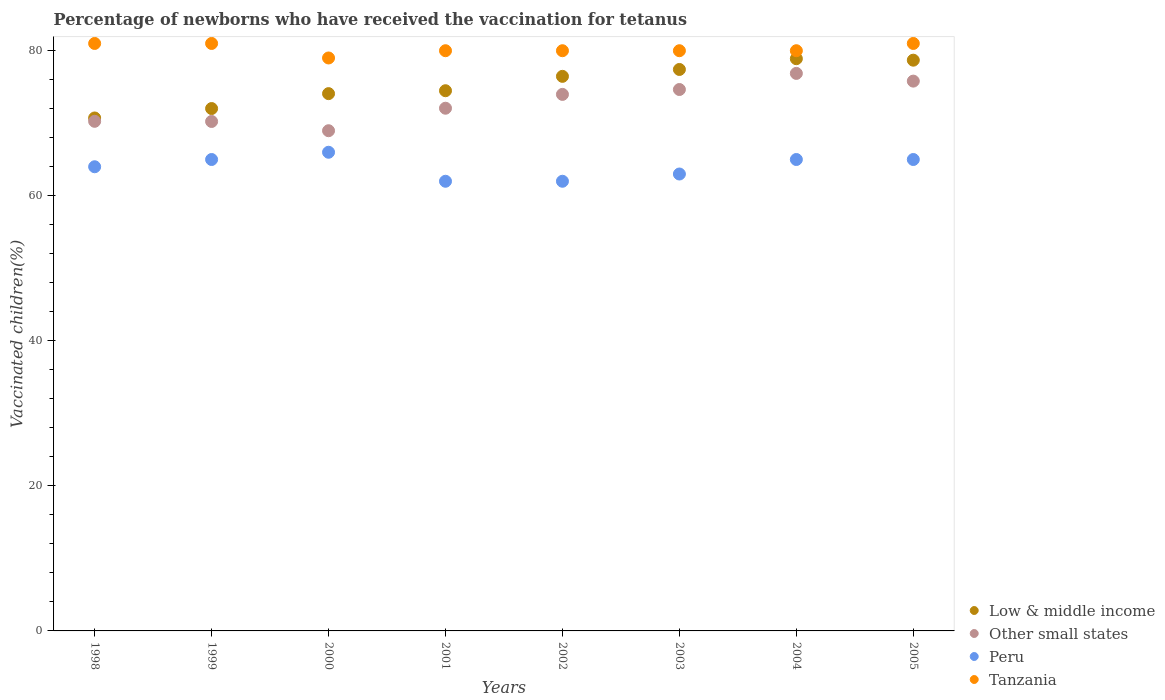How many different coloured dotlines are there?
Offer a terse response. 4. Is the number of dotlines equal to the number of legend labels?
Provide a succinct answer. Yes. What is the percentage of vaccinated children in Tanzania in 2004?
Provide a succinct answer. 80. Across all years, what is the maximum percentage of vaccinated children in Tanzania?
Your answer should be compact. 81. Across all years, what is the minimum percentage of vaccinated children in Tanzania?
Provide a succinct answer. 79. In which year was the percentage of vaccinated children in Tanzania maximum?
Offer a terse response. 1998. What is the total percentage of vaccinated children in Low & middle income in the graph?
Your answer should be very brief. 602.8. What is the difference between the percentage of vaccinated children in Tanzania in 1998 and that in 2004?
Provide a short and direct response. 1. What is the average percentage of vaccinated children in Peru per year?
Keep it short and to the point. 64. In the year 2002, what is the difference between the percentage of vaccinated children in Low & middle income and percentage of vaccinated children in Peru?
Ensure brevity in your answer.  14.47. What is the ratio of the percentage of vaccinated children in Other small states in 2001 to that in 2003?
Your answer should be compact. 0.97. What is the difference between the highest and the second highest percentage of vaccinated children in Tanzania?
Your answer should be compact. 0. What is the difference between the highest and the lowest percentage of vaccinated children in Other small states?
Provide a short and direct response. 7.9. In how many years, is the percentage of vaccinated children in Peru greater than the average percentage of vaccinated children in Peru taken over all years?
Offer a very short reply. 4. Is the sum of the percentage of vaccinated children in Other small states in 1999 and 2003 greater than the maximum percentage of vaccinated children in Tanzania across all years?
Your answer should be very brief. Yes. Is it the case that in every year, the sum of the percentage of vaccinated children in Peru and percentage of vaccinated children in Other small states  is greater than the sum of percentage of vaccinated children in Tanzania and percentage of vaccinated children in Low & middle income?
Make the answer very short. Yes. Is it the case that in every year, the sum of the percentage of vaccinated children in Other small states and percentage of vaccinated children in Tanzania  is greater than the percentage of vaccinated children in Low & middle income?
Keep it short and to the point. Yes. How many dotlines are there?
Keep it short and to the point. 4. How many years are there in the graph?
Your answer should be compact. 8. What is the difference between two consecutive major ticks on the Y-axis?
Your answer should be very brief. 20. Are the values on the major ticks of Y-axis written in scientific E-notation?
Offer a very short reply. No. Does the graph contain any zero values?
Ensure brevity in your answer.  No. Does the graph contain grids?
Provide a short and direct response. No. What is the title of the graph?
Keep it short and to the point. Percentage of newborns who have received the vaccination for tetanus. Does "Gambia, The" appear as one of the legend labels in the graph?
Your answer should be very brief. No. What is the label or title of the Y-axis?
Your answer should be compact. Vaccinated children(%). What is the Vaccinated children(%) in Low & middle income in 1998?
Provide a succinct answer. 70.73. What is the Vaccinated children(%) in Other small states in 1998?
Offer a very short reply. 70.27. What is the Vaccinated children(%) in Low & middle income in 1999?
Offer a terse response. 72.03. What is the Vaccinated children(%) of Other small states in 1999?
Your response must be concise. 70.24. What is the Vaccinated children(%) of Tanzania in 1999?
Provide a short and direct response. 81. What is the Vaccinated children(%) of Low & middle income in 2000?
Your answer should be very brief. 74.08. What is the Vaccinated children(%) in Other small states in 2000?
Your answer should be very brief. 68.97. What is the Vaccinated children(%) in Tanzania in 2000?
Your response must be concise. 79. What is the Vaccinated children(%) of Low & middle income in 2001?
Ensure brevity in your answer.  74.48. What is the Vaccinated children(%) in Other small states in 2001?
Offer a terse response. 72.07. What is the Vaccinated children(%) of Tanzania in 2001?
Ensure brevity in your answer.  80. What is the Vaccinated children(%) in Low & middle income in 2002?
Ensure brevity in your answer.  76.47. What is the Vaccinated children(%) of Other small states in 2002?
Make the answer very short. 73.98. What is the Vaccinated children(%) in Tanzania in 2002?
Your answer should be very brief. 80. What is the Vaccinated children(%) of Low & middle income in 2003?
Your answer should be compact. 77.41. What is the Vaccinated children(%) in Other small states in 2003?
Keep it short and to the point. 74.65. What is the Vaccinated children(%) of Tanzania in 2003?
Provide a short and direct response. 80. What is the Vaccinated children(%) in Low & middle income in 2004?
Offer a terse response. 78.9. What is the Vaccinated children(%) in Other small states in 2004?
Offer a terse response. 76.87. What is the Vaccinated children(%) of Tanzania in 2004?
Provide a succinct answer. 80. What is the Vaccinated children(%) of Low & middle income in 2005?
Make the answer very short. 78.7. What is the Vaccinated children(%) of Other small states in 2005?
Your answer should be compact. 75.81. What is the Vaccinated children(%) in Peru in 2005?
Keep it short and to the point. 65. Across all years, what is the maximum Vaccinated children(%) of Low & middle income?
Ensure brevity in your answer.  78.9. Across all years, what is the maximum Vaccinated children(%) in Other small states?
Keep it short and to the point. 76.87. Across all years, what is the maximum Vaccinated children(%) of Tanzania?
Your response must be concise. 81. Across all years, what is the minimum Vaccinated children(%) in Low & middle income?
Keep it short and to the point. 70.73. Across all years, what is the minimum Vaccinated children(%) in Other small states?
Keep it short and to the point. 68.97. Across all years, what is the minimum Vaccinated children(%) of Tanzania?
Your response must be concise. 79. What is the total Vaccinated children(%) in Low & middle income in the graph?
Provide a succinct answer. 602.8. What is the total Vaccinated children(%) of Other small states in the graph?
Offer a very short reply. 582.86. What is the total Vaccinated children(%) of Peru in the graph?
Keep it short and to the point. 512. What is the total Vaccinated children(%) of Tanzania in the graph?
Make the answer very short. 642. What is the difference between the Vaccinated children(%) in Low & middle income in 1998 and that in 1999?
Offer a terse response. -1.3. What is the difference between the Vaccinated children(%) in Other small states in 1998 and that in 1999?
Provide a short and direct response. 0.02. What is the difference between the Vaccinated children(%) in Tanzania in 1998 and that in 1999?
Offer a very short reply. 0. What is the difference between the Vaccinated children(%) in Low & middle income in 1998 and that in 2000?
Offer a very short reply. -3.36. What is the difference between the Vaccinated children(%) of Other small states in 1998 and that in 2000?
Offer a terse response. 1.3. What is the difference between the Vaccinated children(%) of Low & middle income in 1998 and that in 2001?
Make the answer very short. -3.76. What is the difference between the Vaccinated children(%) of Other small states in 1998 and that in 2001?
Your answer should be very brief. -1.81. What is the difference between the Vaccinated children(%) in Peru in 1998 and that in 2001?
Keep it short and to the point. 2. What is the difference between the Vaccinated children(%) of Tanzania in 1998 and that in 2001?
Your answer should be compact. 1. What is the difference between the Vaccinated children(%) of Low & middle income in 1998 and that in 2002?
Make the answer very short. -5.74. What is the difference between the Vaccinated children(%) of Other small states in 1998 and that in 2002?
Provide a succinct answer. -3.71. What is the difference between the Vaccinated children(%) of Tanzania in 1998 and that in 2002?
Provide a short and direct response. 1. What is the difference between the Vaccinated children(%) in Low & middle income in 1998 and that in 2003?
Keep it short and to the point. -6.69. What is the difference between the Vaccinated children(%) of Other small states in 1998 and that in 2003?
Offer a terse response. -4.38. What is the difference between the Vaccinated children(%) in Low & middle income in 1998 and that in 2004?
Provide a succinct answer. -8.17. What is the difference between the Vaccinated children(%) of Other small states in 1998 and that in 2004?
Provide a succinct answer. -6.61. What is the difference between the Vaccinated children(%) of Peru in 1998 and that in 2004?
Offer a terse response. -1. What is the difference between the Vaccinated children(%) of Low & middle income in 1998 and that in 2005?
Ensure brevity in your answer.  -7.97. What is the difference between the Vaccinated children(%) in Other small states in 1998 and that in 2005?
Provide a short and direct response. -5.54. What is the difference between the Vaccinated children(%) in Peru in 1998 and that in 2005?
Keep it short and to the point. -1. What is the difference between the Vaccinated children(%) in Tanzania in 1998 and that in 2005?
Make the answer very short. 0. What is the difference between the Vaccinated children(%) of Low & middle income in 1999 and that in 2000?
Your response must be concise. -2.06. What is the difference between the Vaccinated children(%) in Other small states in 1999 and that in 2000?
Make the answer very short. 1.27. What is the difference between the Vaccinated children(%) of Tanzania in 1999 and that in 2000?
Your response must be concise. 2. What is the difference between the Vaccinated children(%) in Low & middle income in 1999 and that in 2001?
Offer a very short reply. -2.46. What is the difference between the Vaccinated children(%) in Other small states in 1999 and that in 2001?
Keep it short and to the point. -1.83. What is the difference between the Vaccinated children(%) in Peru in 1999 and that in 2001?
Offer a terse response. 3. What is the difference between the Vaccinated children(%) of Tanzania in 1999 and that in 2001?
Your answer should be very brief. 1. What is the difference between the Vaccinated children(%) of Low & middle income in 1999 and that in 2002?
Make the answer very short. -4.44. What is the difference between the Vaccinated children(%) of Other small states in 1999 and that in 2002?
Your answer should be compact. -3.73. What is the difference between the Vaccinated children(%) of Peru in 1999 and that in 2002?
Ensure brevity in your answer.  3. What is the difference between the Vaccinated children(%) in Tanzania in 1999 and that in 2002?
Offer a very short reply. 1. What is the difference between the Vaccinated children(%) in Low & middle income in 1999 and that in 2003?
Your answer should be very brief. -5.39. What is the difference between the Vaccinated children(%) of Other small states in 1999 and that in 2003?
Keep it short and to the point. -4.41. What is the difference between the Vaccinated children(%) of Tanzania in 1999 and that in 2003?
Ensure brevity in your answer.  1. What is the difference between the Vaccinated children(%) of Low & middle income in 1999 and that in 2004?
Your response must be concise. -6.87. What is the difference between the Vaccinated children(%) in Other small states in 1999 and that in 2004?
Your answer should be compact. -6.63. What is the difference between the Vaccinated children(%) of Tanzania in 1999 and that in 2004?
Your answer should be very brief. 1. What is the difference between the Vaccinated children(%) in Low & middle income in 1999 and that in 2005?
Give a very brief answer. -6.67. What is the difference between the Vaccinated children(%) of Other small states in 1999 and that in 2005?
Give a very brief answer. -5.56. What is the difference between the Vaccinated children(%) of Peru in 1999 and that in 2005?
Offer a terse response. 0. What is the difference between the Vaccinated children(%) of Tanzania in 1999 and that in 2005?
Keep it short and to the point. 0. What is the difference between the Vaccinated children(%) of Low & middle income in 2000 and that in 2001?
Your answer should be very brief. -0.4. What is the difference between the Vaccinated children(%) of Other small states in 2000 and that in 2001?
Your response must be concise. -3.1. What is the difference between the Vaccinated children(%) of Peru in 2000 and that in 2001?
Your answer should be compact. 4. What is the difference between the Vaccinated children(%) in Tanzania in 2000 and that in 2001?
Give a very brief answer. -1. What is the difference between the Vaccinated children(%) of Low & middle income in 2000 and that in 2002?
Keep it short and to the point. -2.38. What is the difference between the Vaccinated children(%) in Other small states in 2000 and that in 2002?
Keep it short and to the point. -5.01. What is the difference between the Vaccinated children(%) of Tanzania in 2000 and that in 2002?
Offer a terse response. -1. What is the difference between the Vaccinated children(%) of Low & middle income in 2000 and that in 2003?
Your answer should be compact. -3.33. What is the difference between the Vaccinated children(%) in Other small states in 2000 and that in 2003?
Make the answer very short. -5.68. What is the difference between the Vaccinated children(%) in Tanzania in 2000 and that in 2003?
Your response must be concise. -1. What is the difference between the Vaccinated children(%) of Low & middle income in 2000 and that in 2004?
Give a very brief answer. -4.82. What is the difference between the Vaccinated children(%) in Other small states in 2000 and that in 2004?
Keep it short and to the point. -7.9. What is the difference between the Vaccinated children(%) in Peru in 2000 and that in 2004?
Your response must be concise. 1. What is the difference between the Vaccinated children(%) in Low & middle income in 2000 and that in 2005?
Provide a short and direct response. -4.61. What is the difference between the Vaccinated children(%) of Other small states in 2000 and that in 2005?
Your answer should be very brief. -6.84. What is the difference between the Vaccinated children(%) of Low & middle income in 2001 and that in 2002?
Your answer should be very brief. -1.98. What is the difference between the Vaccinated children(%) in Other small states in 2001 and that in 2002?
Offer a terse response. -1.91. What is the difference between the Vaccinated children(%) of Tanzania in 2001 and that in 2002?
Provide a short and direct response. 0. What is the difference between the Vaccinated children(%) of Low & middle income in 2001 and that in 2003?
Provide a succinct answer. -2.93. What is the difference between the Vaccinated children(%) of Other small states in 2001 and that in 2003?
Provide a short and direct response. -2.58. What is the difference between the Vaccinated children(%) of Low & middle income in 2001 and that in 2004?
Your answer should be very brief. -4.42. What is the difference between the Vaccinated children(%) in Other small states in 2001 and that in 2004?
Your answer should be compact. -4.8. What is the difference between the Vaccinated children(%) in Peru in 2001 and that in 2004?
Provide a succinct answer. -3. What is the difference between the Vaccinated children(%) in Low & middle income in 2001 and that in 2005?
Offer a terse response. -4.21. What is the difference between the Vaccinated children(%) in Other small states in 2001 and that in 2005?
Ensure brevity in your answer.  -3.74. What is the difference between the Vaccinated children(%) in Peru in 2001 and that in 2005?
Provide a short and direct response. -3. What is the difference between the Vaccinated children(%) in Tanzania in 2001 and that in 2005?
Provide a short and direct response. -1. What is the difference between the Vaccinated children(%) of Low & middle income in 2002 and that in 2003?
Provide a succinct answer. -0.95. What is the difference between the Vaccinated children(%) in Other small states in 2002 and that in 2003?
Your answer should be very brief. -0.67. What is the difference between the Vaccinated children(%) of Low & middle income in 2002 and that in 2004?
Make the answer very short. -2.43. What is the difference between the Vaccinated children(%) of Other small states in 2002 and that in 2004?
Your answer should be compact. -2.9. What is the difference between the Vaccinated children(%) of Low & middle income in 2002 and that in 2005?
Offer a very short reply. -2.23. What is the difference between the Vaccinated children(%) in Other small states in 2002 and that in 2005?
Your answer should be very brief. -1.83. What is the difference between the Vaccinated children(%) of Low & middle income in 2003 and that in 2004?
Offer a terse response. -1.48. What is the difference between the Vaccinated children(%) in Other small states in 2003 and that in 2004?
Make the answer very short. -2.22. What is the difference between the Vaccinated children(%) of Tanzania in 2003 and that in 2004?
Make the answer very short. 0. What is the difference between the Vaccinated children(%) in Low & middle income in 2003 and that in 2005?
Provide a succinct answer. -1.28. What is the difference between the Vaccinated children(%) of Other small states in 2003 and that in 2005?
Give a very brief answer. -1.16. What is the difference between the Vaccinated children(%) of Peru in 2003 and that in 2005?
Offer a very short reply. -2. What is the difference between the Vaccinated children(%) in Low & middle income in 2004 and that in 2005?
Your answer should be very brief. 0.2. What is the difference between the Vaccinated children(%) of Other small states in 2004 and that in 2005?
Your answer should be very brief. 1.06. What is the difference between the Vaccinated children(%) of Peru in 2004 and that in 2005?
Provide a succinct answer. 0. What is the difference between the Vaccinated children(%) in Low & middle income in 1998 and the Vaccinated children(%) in Other small states in 1999?
Your answer should be very brief. 0.48. What is the difference between the Vaccinated children(%) of Low & middle income in 1998 and the Vaccinated children(%) of Peru in 1999?
Your answer should be compact. 5.73. What is the difference between the Vaccinated children(%) in Low & middle income in 1998 and the Vaccinated children(%) in Tanzania in 1999?
Give a very brief answer. -10.27. What is the difference between the Vaccinated children(%) of Other small states in 1998 and the Vaccinated children(%) of Peru in 1999?
Your answer should be very brief. 5.27. What is the difference between the Vaccinated children(%) in Other small states in 1998 and the Vaccinated children(%) in Tanzania in 1999?
Your answer should be very brief. -10.73. What is the difference between the Vaccinated children(%) of Peru in 1998 and the Vaccinated children(%) of Tanzania in 1999?
Make the answer very short. -17. What is the difference between the Vaccinated children(%) in Low & middle income in 1998 and the Vaccinated children(%) in Other small states in 2000?
Ensure brevity in your answer.  1.76. What is the difference between the Vaccinated children(%) in Low & middle income in 1998 and the Vaccinated children(%) in Peru in 2000?
Provide a short and direct response. 4.73. What is the difference between the Vaccinated children(%) in Low & middle income in 1998 and the Vaccinated children(%) in Tanzania in 2000?
Offer a terse response. -8.27. What is the difference between the Vaccinated children(%) in Other small states in 1998 and the Vaccinated children(%) in Peru in 2000?
Provide a succinct answer. 4.27. What is the difference between the Vaccinated children(%) of Other small states in 1998 and the Vaccinated children(%) of Tanzania in 2000?
Your response must be concise. -8.73. What is the difference between the Vaccinated children(%) of Peru in 1998 and the Vaccinated children(%) of Tanzania in 2000?
Your response must be concise. -15. What is the difference between the Vaccinated children(%) in Low & middle income in 1998 and the Vaccinated children(%) in Other small states in 2001?
Make the answer very short. -1.34. What is the difference between the Vaccinated children(%) in Low & middle income in 1998 and the Vaccinated children(%) in Peru in 2001?
Your answer should be very brief. 8.73. What is the difference between the Vaccinated children(%) in Low & middle income in 1998 and the Vaccinated children(%) in Tanzania in 2001?
Give a very brief answer. -9.27. What is the difference between the Vaccinated children(%) in Other small states in 1998 and the Vaccinated children(%) in Peru in 2001?
Give a very brief answer. 8.27. What is the difference between the Vaccinated children(%) of Other small states in 1998 and the Vaccinated children(%) of Tanzania in 2001?
Ensure brevity in your answer.  -9.73. What is the difference between the Vaccinated children(%) in Peru in 1998 and the Vaccinated children(%) in Tanzania in 2001?
Offer a very short reply. -16. What is the difference between the Vaccinated children(%) of Low & middle income in 1998 and the Vaccinated children(%) of Other small states in 2002?
Provide a short and direct response. -3.25. What is the difference between the Vaccinated children(%) in Low & middle income in 1998 and the Vaccinated children(%) in Peru in 2002?
Offer a terse response. 8.73. What is the difference between the Vaccinated children(%) in Low & middle income in 1998 and the Vaccinated children(%) in Tanzania in 2002?
Keep it short and to the point. -9.27. What is the difference between the Vaccinated children(%) of Other small states in 1998 and the Vaccinated children(%) of Peru in 2002?
Offer a very short reply. 8.27. What is the difference between the Vaccinated children(%) of Other small states in 1998 and the Vaccinated children(%) of Tanzania in 2002?
Provide a short and direct response. -9.73. What is the difference between the Vaccinated children(%) of Peru in 1998 and the Vaccinated children(%) of Tanzania in 2002?
Provide a succinct answer. -16. What is the difference between the Vaccinated children(%) of Low & middle income in 1998 and the Vaccinated children(%) of Other small states in 2003?
Your response must be concise. -3.92. What is the difference between the Vaccinated children(%) in Low & middle income in 1998 and the Vaccinated children(%) in Peru in 2003?
Offer a terse response. 7.73. What is the difference between the Vaccinated children(%) of Low & middle income in 1998 and the Vaccinated children(%) of Tanzania in 2003?
Your answer should be compact. -9.27. What is the difference between the Vaccinated children(%) of Other small states in 1998 and the Vaccinated children(%) of Peru in 2003?
Give a very brief answer. 7.27. What is the difference between the Vaccinated children(%) in Other small states in 1998 and the Vaccinated children(%) in Tanzania in 2003?
Give a very brief answer. -9.73. What is the difference between the Vaccinated children(%) in Low & middle income in 1998 and the Vaccinated children(%) in Other small states in 2004?
Keep it short and to the point. -6.15. What is the difference between the Vaccinated children(%) of Low & middle income in 1998 and the Vaccinated children(%) of Peru in 2004?
Make the answer very short. 5.73. What is the difference between the Vaccinated children(%) of Low & middle income in 1998 and the Vaccinated children(%) of Tanzania in 2004?
Offer a very short reply. -9.27. What is the difference between the Vaccinated children(%) of Other small states in 1998 and the Vaccinated children(%) of Peru in 2004?
Offer a terse response. 5.27. What is the difference between the Vaccinated children(%) in Other small states in 1998 and the Vaccinated children(%) in Tanzania in 2004?
Provide a succinct answer. -9.73. What is the difference between the Vaccinated children(%) of Low & middle income in 1998 and the Vaccinated children(%) of Other small states in 2005?
Your answer should be compact. -5.08. What is the difference between the Vaccinated children(%) in Low & middle income in 1998 and the Vaccinated children(%) in Peru in 2005?
Ensure brevity in your answer.  5.73. What is the difference between the Vaccinated children(%) of Low & middle income in 1998 and the Vaccinated children(%) of Tanzania in 2005?
Your answer should be very brief. -10.27. What is the difference between the Vaccinated children(%) in Other small states in 1998 and the Vaccinated children(%) in Peru in 2005?
Ensure brevity in your answer.  5.27. What is the difference between the Vaccinated children(%) in Other small states in 1998 and the Vaccinated children(%) in Tanzania in 2005?
Offer a terse response. -10.73. What is the difference between the Vaccinated children(%) of Low & middle income in 1999 and the Vaccinated children(%) of Other small states in 2000?
Keep it short and to the point. 3.06. What is the difference between the Vaccinated children(%) in Low & middle income in 1999 and the Vaccinated children(%) in Peru in 2000?
Your response must be concise. 6.03. What is the difference between the Vaccinated children(%) in Low & middle income in 1999 and the Vaccinated children(%) in Tanzania in 2000?
Offer a terse response. -6.97. What is the difference between the Vaccinated children(%) in Other small states in 1999 and the Vaccinated children(%) in Peru in 2000?
Provide a short and direct response. 4.24. What is the difference between the Vaccinated children(%) in Other small states in 1999 and the Vaccinated children(%) in Tanzania in 2000?
Make the answer very short. -8.76. What is the difference between the Vaccinated children(%) in Low & middle income in 1999 and the Vaccinated children(%) in Other small states in 2001?
Your response must be concise. -0.04. What is the difference between the Vaccinated children(%) of Low & middle income in 1999 and the Vaccinated children(%) of Peru in 2001?
Your response must be concise. 10.03. What is the difference between the Vaccinated children(%) in Low & middle income in 1999 and the Vaccinated children(%) in Tanzania in 2001?
Make the answer very short. -7.97. What is the difference between the Vaccinated children(%) in Other small states in 1999 and the Vaccinated children(%) in Peru in 2001?
Ensure brevity in your answer.  8.24. What is the difference between the Vaccinated children(%) of Other small states in 1999 and the Vaccinated children(%) of Tanzania in 2001?
Keep it short and to the point. -9.76. What is the difference between the Vaccinated children(%) in Low & middle income in 1999 and the Vaccinated children(%) in Other small states in 2002?
Give a very brief answer. -1.95. What is the difference between the Vaccinated children(%) in Low & middle income in 1999 and the Vaccinated children(%) in Peru in 2002?
Provide a succinct answer. 10.03. What is the difference between the Vaccinated children(%) of Low & middle income in 1999 and the Vaccinated children(%) of Tanzania in 2002?
Provide a short and direct response. -7.97. What is the difference between the Vaccinated children(%) in Other small states in 1999 and the Vaccinated children(%) in Peru in 2002?
Give a very brief answer. 8.24. What is the difference between the Vaccinated children(%) in Other small states in 1999 and the Vaccinated children(%) in Tanzania in 2002?
Provide a succinct answer. -9.76. What is the difference between the Vaccinated children(%) in Low & middle income in 1999 and the Vaccinated children(%) in Other small states in 2003?
Ensure brevity in your answer.  -2.62. What is the difference between the Vaccinated children(%) in Low & middle income in 1999 and the Vaccinated children(%) in Peru in 2003?
Ensure brevity in your answer.  9.03. What is the difference between the Vaccinated children(%) of Low & middle income in 1999 and the Vaccinated children(%) of Tanzania in 2003?
Keep it short and to the point. -7.97. What is the difference between the Vaccinated children(%) of Other small states in 1999 and the Vaccinated children(%) of Peru in 2003?
Provide a succinct answer. 7.24. What is the difference between the Vaccinated children(%) in Other small states in 1999 and the Vaccinated children(%) in Tanzania in 2003?
Your response must be concise. -9.76. What is the difference between the Vaccinated children(%) in Peru in 1999 and the Vaccinated children(%) in Tanzania in 2003?
Ensure brevity in your answer.  -15. What is the difference between the Vaccinated children(%) in Low & middle income in 1999 and the Vaccinated children(%) in Other small states in 2004?
Your answer should be very brief. -4.85. What is the difference between the Vaccinated children(%) in Low & middle income in 1999 and the Vaccinated children(%) in Peru in 2004?
Your answer should be very brief. 7.03. What is the difference between the Vaccinated children(%) of Low & middle income in 1999 and the Vaccinated children(%) of Tanzania in 2004?
Make the answer very short. -7.97. What is the difference between the Vaccinated children(%) in Other small states in 1999 and the Vaccinated children(%) in Peru in 2004?
Make the answer very short. 5.24. What is the difference between the Vaccinated children(%) of Other small states in 1999 and the Vaccinated children(%) of Tanzania in 2004?
Ensure brevity in your answer.  -9.76. What is the difference between the Vaccinated children(%) of Peru in 1999 and the Vaccinated children(%) of Tanzania in 2004?
Offer a very short reply. -15. What is the difference between the Vaccinated children(%) in Low & middle income in 1999 and the Vaccinated children(%) in Other small states in 2005?
Provide a short and direct response. -3.78. What is the difference between the Vaccinated children(%) of Low & middle income in 1999 and the Vaccinated children(%) of Peru in 2005?
Ensure brevity in your answer.  7.03. What is the difference between the Vaccinated children(%) in Low & middle income in 1999 and the Vaccinated children(%) in Tanzania in 2005?
Ensure brevity in your answer.  -8.97. What is the difference between the Vaccinated children(%) in Other small states in 1999 and the Vaccinated children(%) in Peru in 2005?
Your answer should be compact. 5.24. What is the difference between the Vaccinated children(%) in Other small states in 1999 and the Vaccinated children(%) in Tanzania in 2005?
Your answer should be compact. -10.76. What is the difference between the Vaccinated children(%) of Peru in 1999 and the Vaccinated children(%) of Tanzania in 2005?
Offer a terse response. -16. What is the difference between the Vaccinated children(%) of Low & middle income in 2000 and the Vaccinated children(%) of Other small states in 2001?
Make the answer very short. 2.01. What is the difference between the Vaccinated children(%) of Low & middle income in 2000 and the Vaccinated children(%) of Peru in 2001?
Make the answer very short. 12.08. What is the difference between the Vaccinated children(%) in Low & middle income in 2000 and the Vaccinated children(%) in Tanzania in 2001?
Give a very brief answer. -5.92. What is the difference between the Vaccinated children(%) of Other small states in 2000 and the Vaccinated children(%) of Peru in 2001?
Make the answer very short. 6.97. What is the difference between the Vaccinated children(%) in Other small states in 2000 and the Vaccinated children(%) in Tanzania in 2001?
Make the answer very short. -11.03. What is the difference between the Vaccinated children(%) in Low & middle income in 2000 and the Vaccinated children(%) in Other small states in 2002?
Make the answer very short. 0.11. What is the difference between the Vaccinated children(%) in Low & middle income in 2000 and the Vaccinated children(%) in Peru in 2002?
Keep it short and to the point. 12.08. What is the difference between the Vaccinated children(%) of Low & middle income in 2000 and the Vaccinated children(%) of Tanzania in 2002?
Your answer should be compact. -5.92. What is the difference between the Vaccinated children(%) in Other small states in 2000 and the Vaccinated children(%) in Peru in 2002?
Make the answer very short. 6.97. What is the difference between the Vaccinated children(%) in Other small states in 2000 and the Vaccinated children(%) in Tanzania in 2002?
Give a very brief answer. -11.03. What is the difference between the Vaccinated children(%) of Peru in 2000 and the Vaccinated children(%) of Tanzania in 2002?
Provide a succinct answer. -14. What is the difference between the Vaccinated children(%) in Low & middle income in 2000 and the Vaccinated children(%) in Other small states in 2003?
Offer a terse response. -0.57. What is the difference between the Vaccinated children(%) of Low & middle income in 2000 and the Vaccinated children(%) of Peru in 2003?
Keep it short and to the point. 11.08. What is the difference between the Vaccinated children(%) of Low & middle income in 2000 and the Vaccinated children(%) of Tanzania in 2003?
Your answer should be compact. -5.92. What is the difference between the Vaccinated children(%) of Other small states in 2000 and the Vaccinated children(%) of Peru in 2003?
Make the answer very short. 5.97. What is the difference between the Vaccinated children(%) in Other small states in 2000 and the Vaccinated children(%) in Tanzania in 2003?
Offer a very short reply. -11.03. What is the difference between the Vaccinated children(%) in Peru in 2000 and the Vaccinated children(%) in Tanzania in 2003?
Give a very brief answer. -14. What is the difference between the Vaccinated children(%) of Low & middle income in 2000 and the Vaccinated children(%) of Other small states in 2004?
Provide a succinct answer. -2.79. What is the difference between the Vaccinated children(%) in Low & middle income in 2000 and the Vaccinated children(%) in Peru in 2004?
Offer a terse response. 9.08. What is the difference between the Vaccinated children(%) of Low & middle income in 2000 and the Vaccinated children(%) of Tanzania in 2004?
Offer a terse response. -5.92. What is the difference between the Vaccinated children(%) of Other small states in 2000 and the Vaccinated children(%) of Peru in 2004?
Make the answer very short. 3.97. What is the difference between the Vaccinated children(%) in Other small states in 2000 and the Vaccinated children(%) in Tanzania in 2004?
Your answer should be compact. -11.03. What is the difference between the Vaccinated children(%) of Peru in 2000 and the Vaccinated children(%) of Tanzania in 2004?
Give a very brief answer. -14. What is the difference between the Vaccinated children(%) of Low & middle income in 2000 and the Vaccinated children(%) of Other small states in 2005?
Make the answer very short. -1.73. What is the difference between the Vaccinated children(%) in Low & middle income in 2000 and the Vaccinated children(%) in Peru in 2005?
Offer a terse response. 9.08. What is the difference between the Vaccinated children(%) of Low & middle income in 2000 and the Vaccinated children(%) of Tanzania in 2005?
Offer a terse response. -6.92. What is the difference between the Vaccinated children(%) in Other small states in 2000 and the Vaccinated children(%) in Peru in 2005?
Offer a terse response. 3.97. What is the difference between the Vaccinated children(%) of Other small states in 2000 and the Vaccinated children(%) of Tanzania in 2005?
Ensure brevity in your answer.  -12.03. What is the difference between the Vaccinated children(%) in Peru in 2000 and the Vaccinated children(%) in Tanzania in 2005?
Make the answer very short. -15. What is the difference between the Vaccinated children(%) in Low & middle income in 2001 and the Vaccinated children(%) in Other small states in 2002?
Offer a very short reply. 0.51. What is the difference between the Vaccinated children(%) of Low & middle income in 2001 and the Vaccinated children(%) of Peru in 2002?
Provide a succinct answer. 12.48. What is the difference between the Vaccinated children(%) of Low & middle income in 2001 and the Vaccinated children(%) of Tanzania in 2002?
Give a very brief answer. -5.52. What is the difference between the Vaccinated children(%) in Other small states in 2001 and the Vaccinated children(%) in Peru in 2002?
Provide a short and direct response. 10.07. What is the difference between the Vaccinated children(%) of Other small states in 2001 and the Vaccinated children(%) of Tanzania in 2002?
Give a very brief answer. -7.93. What is the difference between the Vaccinated children(%) of Peru in 2001 and the Vaccinated children(%) of Tanzania in 2002?
Offer a very short reply. -18. What is the difference between the Vaccinated children(%) in Low & middle income in 2001 and the Vaccinated children(%) in Other small states in 2003?
Keep it short and to the point. -0.17. What is the difference between the Vaccinated children(%) in Low & middle income in 2001 and the Vaccinated children(%) in Peru in 2003?
Your answer should be compact. 11.48. What is the difference between the Vaccinated children(%) in Low & middle income in 2001 and the Vaccinated children(%) in Tanzania in 2003?
Your response must be concise. -5.52. What is the difference between the Vaccinated children(%) of Other small states in 2001 and the Vaccinated children(%) of Peru in 2003?
Provide a succinct answer. 9.07. What is the difference between the Vaccinated children(%) in Other small states in 2001 and the Vaccinated children(%) in Tanzania in 2003?
Offer a terse response. -7.93. What is the difference between the Vaccinated children(%) of Peru in 2001 and the Vaccinated children(%) of Tanzania in 2003?
Keep it short and to the point. -18. What is the difference between the Vaccinated children(%) in Low & middle income in 2001 and the Vaccinated children(%) in Other small states in 2004?
Make the answer very short. -2.39. What is the difference between the Vaccinated children(%) in Low & middle income in 2001 and the Vaccinated children(%) in Peru in 2004?
Offer a terse response. 9.48. What is the difference between the Vaccinated children(%) of Low & middle income in 2001 and the Vaccinated children(%) of Tanzania in 2004?
Make the answer very short. -5.52. What is the difference between the Vaccinated children(%) of Other small states in 2001 and the Vaccinated children(%) of Peru in 2004?
Your answer should be very brief. 7.07. What is the difference between the Vaccinated children(%) in Other small states in 2001 and the Vaccinated children(%) in Tanzania in 2004?
Your answer should be compact. -7.93. What is the difference between the Vaccinated children(%) of Low & middle income in 2001 and the Vaccinated children(%) of Other small states in 2005?
Your answer should be very brief. -1.32. What is the difference between the Vaccinated children(%) of Low & middle income in 2001 and the Vaccinated children(%) of Peru in 2005?
Offer a very short reply. 9.48. What is the difference between the Vaccinated children(%) in Low & middle income in 2001 and the Vaccinated children(%) in Tanzania in 2005?
Give a very brief answer. -6.52. What is the difference between the Vaccinated children(%) in Other small states in 2001 and the Vaccinated children(%) in Peru in 2005?
Keep it short and to the point. 7.07. What is the difference between the Vaccinated children(%) in Other small states in 2001 and the Vaccinated children(%) in Tanzania in 2005?
Give a very brief answer. -8.93. What is the difference between the Vaccinated children(%) of Low & middle income in 2002 and the Vaccinated children(%) of Other small states in 2003?
Your answer should be compact. 1.81. What is the difference between the Vaccinated children(%) of Low & middle income in 2002 and the Vaccinated children(%) of Peru in 2003?
Provide a succinct answer. 13.47. What is the difference between the Vaccinated children(%) of Low & middle income in 2002 and the Vaccinated children(%) of Tanzania in 2003?
Offer a very short reply. -3.53. What is the difference between the Vaccinated children(%) in Other small states in 2002 and the Vaccinated children(%) in Peru in 2003?
Make the answer very short. 10.98. What is the difference between the Vaccinated children(%) in Other small states in 2002 and the Vaccinated children(%) in Tanzania in 2003?
Provide a succinct answer. -6.02. What is the difference between the Vaccinated children(%) of Low & middle income in 2002 and the Vaccinated children(%) of Other small states in 2004?
Your response must be concise. -0.41. What is the difference between the Vaccinated children(%) of Low & middle income in 2002 and the Vaccinated children(%) of Peru in 2004?
Offer a very short reply. 11.47. What is the difference between the Vaccinated children(%) in Low & middle income in 2002 and the Vaccinated children(%) in Tanzania in 2004?
Your response must be concise. -3.53. What is the difference between the Vaccinated children(%) of Other small states in 2002 and the Vaccinated children(%) of Peru in 2004?
Provide a short and direct response. 8.98. What is the difference between the Vaccinated children(%) of Other small states in 2002 and the Vaccinated children(%) of Tanzania in 2004?
Provide a short and direct response. -6.02. What is the difference between the Vaccinated children(%) of Low & middle income in 2002 and the Vaccinated children(%) of Other small states in 2005?
Give a very brief answer. 0.66. What is the difference between the Vaccinated children(%) in Low & middle income in 2002 and the Vaccinated children(%) in Peru in 2005?
Your response must be concise. 11.47. What is the difference between the Vaccinated children(%) in Low & middle income in 2002 and the Vaccinated children(%) in Tanzania in 2005?
Offer a terse response. -4.53. What is the difference between the Vaccinated children(%) in Other small states in 2002 and the Vaccinated children(%) in Peru in 2005?
Offer a terse response. 8.98. What is the difference between the Vaccinated children(%) in Other small states in 2002 and the Vaccinated children(%) in Tanzania in 2005?
Offer a very short reply. -7.02. What is the difference between the Vaccinated children(%) of Low & middle income in 2003 and the Vaccinated children(%) of Other small states in 2004?
Offer a terse response. 0.54. What is the difference between the Vaccinated children(%) in Low & middle income in 2003 and the Vaccinated children(%) in Peru in 2004?
Ensure brevity in your answer.  12.41. What is the difference between the Vaccinated children(%) in Low & middle income in 2003 and the Vaccinated children(%) in Tanzania in 2004?
Ensure brevity in your answer.  -2.59. What is the difference between the Vaccinated children(%) in Other small states in 2003 and the Vaccinated children(%) in Peru in 2004?
Provide a succinct answer. 9.65. What is the difference between the Vaccinated children(%) in Other small states in 2003 and the Vaccinated children(%) in Tanzania in 2004?
Keep it short and to the point. -5.35. What is the difference between the Vaccinated children(%) in Peru in 2003 and the Vaccinated children(%) in Tanzania in 2004?
Make the answer very short. -17. What is the difference between the Vaccinated children(%) of Low & middle income in 2003 and the Vaccinated children(%) of Other small states in 2005?
Your response must be concise. 1.61. What is the difference between the Vaccinated children(%) in Low & middle income in 2003 and the Vaccinated children(%) in Peru in 2005?
Your response must be concise. 12.41. What is the difference between the Vaccinated children(%) in Low & middle income in 2003 and the Vaccinated children(%) in Tanzania in 2005?
Your answer should be compact. -3.59. What is the difference between the Vaccinated children(%) in Other small states in 2003 and the Vaccinated children(%) in Peru in 2005?
Your response must be concise. 9.65. What is the difference between the Vaccinated children(%) of Other small states in 2003 and the Vaccinated children(%) of Tanzania in 2005?
Provide a succinct answer. -6.35. What is the difference between the Vaccinated children(%) of Low & middle income in 2004 and the Vaccinated children(%) of Other small states in 2005?
Make the answer very short. 3.09. What is the difference between the Vaccinated children(%) of Low & middle income in 2004 and the Vaccinated children(%) of Peru in 2005?
Your response must be concise. 13.9. What is the difference between the Vaccinated children(%) of Low & middle income in 2004 and the Vaccinated children(%) of Tanzania in 2005?
Your answer should be compact. -2.1. What is the difference between the Vaccinated children(%) of Other small states in 2004 and the Vaccinated children(%) of Peru in 2005?
Keep it short and to the point. 11.87. What is the difference between the Vaccinated children(%) of Other small states in 2004 and the Vaccinated children(%) of Tanzania in 2005?
Your response must be concise. -4.13. What is the difference between the Vaccinated children(%) in Peru in 2004 and the Vaccinated children(%) in Tanzania in 2005?
Provide a short and direct response. -16. What is the average Vaccinated children(%) of Low & middle income per year?
Your response must be concise. 75.35. What is the average Vaccinated children(%) in Other small states per year?
Offer a very short reply. 72.86. What is the average Vaccinated children(%) in Tanzania per year?
Your response must be concise. 80.25. In the year 1998, what is the difference between the Vaccinated children(%) of Low & middle income and Vaccinated children(%) of Other small states?
Make the answer very short. 0.46. In the year 1998, what is the difference between the Vaccinated children(%) of Low & middle income and Vaccinated children(%) of Peru?
Your response must be concise. 6.73. In the year 1998, what is the difference between the Vaccinated children(%) of Low & middle income and Vaccinated children(%) of Tanzania?
Your answer should be very brief. -10.27. In the year 1998, what is the difference between the Vaccinated children(%) in Other small states and Vaccinated children(%) in Peru?
Offer a very short reply. 6.27. In the year 1998, what is the difference between the Vaccinated children(%) of Other small states and Vaccinated children(%) of Tanzania?
Your answer should be very brief. -10.73. In the year 1998, what is the difference between the Vaccinated children(%) in Peru and Vaccinated children(%) in Tanzania?
Provide a succinct answer. -17. In the year 1999, what is the difference between the Vaccinated children(%) in Low & middle income and Vaccinated children(%) in Other small states?
Your answer should be compact. 1.78. In the year 1999, what is the difference between the Vaccinated children(%) of Low & middle income and Vaccinated children(%) of Peru?
Offer a terse response. 7.03. In the year 1999, what is the difference between the Vaccinated children(%) of Low & middle income and Vaccinated children(%) of Tanzania?
Give a very brief answer. -8.97. In the year 1999, what is the difference between the Vaccinated children(%) of Other small states and Vaccinated children(%) of Peru?
Offer a terse response. 5.24. In the year 1999, what is the difference between the Vaccinated children(%) in Other small states and Vaccinated children(%) in Tanzania?
Provide a succinct answer. -10.76. In the year 2000, what is the difference between the Vaccinated children(%) of Low & middle income and Vaccinated children(%) of Other small states?
Your answer should be very brief. 5.11. In the year 2000, what is the difference between the Vaccinated children(%) in Low & middle income and Vaccinated children(%) in Peru?
Provide a short and direct response. 8.08. In the year 2000, what is the difference between the Vaccinated children(%) in Low & middle income and Vaccinated children(%) in Tanzania?
Your answer should be very brief. -4.92. In the year 2000, what is the difference between the Vaccinated children(%) of Other small states and Vaccinated children(%) of Peru?
Your answer should be compact. 2.97. In the year 2000, what is the difference between the Vaccinated children(%) of Other small states and Vaccinated children(%) of Tanzania?
Provide a short and direct response. -10.03. In the year 2001, what is the difference between the Vaccinated children(%) of Low & middle income and Vaccinated children(%) of Other small states?
Make the answer very short. 2.41. In the year 2001, what is the difference between the Vaccinated children(%) of Low & middle income and Vaccinated children(%) of Peru?
Keep it short and to the point. 12.48. In the year 2001, what is the difference between the Vaccinated children(%) in Low & middle income and Vaccinated children(%) in Tanzania?
Ensure brevity in your answer.  -5.52. In the year 2001, what is the difference between the Vaccinated children(%) of Other small states and Vaccinated children(%) of Peru?
Offer a terse response. 10.07. In the year 2001, what is the difference between the Vaccinated children(%) in Other small states and Vaccinated children(%) in Tanzania?
Provide a succinct answer. -7.93. In the year 2002, what is the difference between the Vaccinated children(%) of Low & middle income and Vaccinated children(%) of Other small states?
Provide a short and direct response. 2.49. In the year 2002, what is the difference between the Vaccinated children(%) in Low & middle income and Vaccinated children(%) in Peru?
Give a very brief answer. 14.47. In the year 2002, what is the difference between the Vaccinated children(%) in Low & middle income and Vaccinated children(%) in Tanzania?
Offer a very short reply. -3.53. In the year 2002, what is the difference between the Vaccinated children(%) in Other small states and Vaccinated children(%) in Peru?
Ensure brevity in your answer.  11.98. In the year 2002, what is the difference between the Vaccinated children(%) in Other small states and Vaccinated children(%) in Tanzania?
Make the answer very short. -6.02. In the year 2002, what is the difference between the Vaccinated children(%) in Peru and Vaccinated children(%) in Tanzania?
Provide a succinct answer. -18. In the year 2003, what is the difference between the Vaccinated children(%) in Low & middle income and Vaccinated children(%) in Other small states?
Your answer should be compact. 2.76. In the year 2003, what is the difference between the Vaccinated children(%) of Low & middle income and Vaccinated children(%) of Peru?
Give a very brief answer. 14.41. In the year 2003, what is the difference between the Vaccinated children(%) in Low & middle income and Vaccinated children(%) in Tanzania?
Offer a terse response. -2.59. In the year 2003, what is the difference between the Vaccinated children(%) in Other small states and Vaccinated children(%) in Peru?
Offer a terse response. 11.65. In the year 2003, what is the difference between the Vaccinated children(%) in Other small states and Vaccinated children(%) in Tanzania?
Make the answer very short. -5.35. In the year 2004, what is the difference between the Vaccinated children(%) of Low & middle income and Vaccinated children(%) of Other small states?
Your response must be concise. 2.03. In the year 2004, what is the difference between the Vaccinated children(%) of Low & middle income and Vaccinated children(%) of Peru?
Give a very brief answer. 13.9. In the year 2004, what is the difference between the Vaccinated children(%) in Low & middle income and Vaccinated children(%) in Tanzania?
Provide a succinct answer. -1.1. In the year 2004, what is the difference between the Vaccinated children(%) of Other small states and Vaccinated children(%) of Peru?
Keep it short and to the point. 11.87. In the year 2004, what is the difference between the Vaccinated children(%) of Other small states and Vaccinated children(%) of Tanzania?
Offer a terse response. -3.13. In the year 2004, what is the difference between the Vaccinated children(%) of Peru and Vaccinated children(%) of Tanzania?
Ensure brevity in your answer.  -15. In the year 2005, what is the difference between the Vaccinated children(%) in Low & middle income and Vaccinated children(%) in Other small states?
Make the answer very short. 2.89. In the year 2005, what is the difference between the Vaccinated children(%) in Low & middle income and Vaccinated children(%) in Peru?
Offer a terse response. 13.7. In the year 2005, what is the difference between the Vaccinated children(%) in Low & middle income and Vaccinated children(%) in Tanzania?
Your response must be concise. -2.3. In the year 2005, what is the difference between the Vaccinated children(%) in Other small states and Vaccinated children(%) in Peru?
Ensure brevity in your answer.  10.81. In the year 2005, what is the difference between the Vaccinated children(%) of Other small states and Vaccinated children(%) of Tanzania?
Give a very brief answer. -5.19. In the year 2005, what is the difference between the Vaccinated children(%) of Peru and Vaccinated children(%) of Tanzania?
Ensure brevity in your answer.  -16. What is the ratio of the Vaccinated children(%) of Low & middle income in 1998 to that in 1999?
Give a very brief answer. 0.98. What is the ratio of the Vaccinated children(%) of Other small states in 1998 to that in 1999?
Ensure brevity in your answer.  1. What is the ratio of the Vaccinated children(%) of Peru in 1998 to that in 1999?
Your answer should be very brief. 0.98. What is the ratio of the Vaccinated children(%) in Tanzania in 1998 to that in 1999?
Provide a short and direct response. 1. What is the ratio of the Vaccinated children(%) of Low & middle income in 1998 to that in 2000?
Your answer should be very brief. 0.95. What is the ratio of the Vaccinated children(%) in Other small states in 1998 to that in 2000?
Ensure brevity in your answer.  1.02. What is the ratio of the Vaccinated children(%) in Peru in 1998 to that in 2000?
Offer a terse response. 0.97. What is the ratio of the Vaccinated children(%) of Tanzania in 1998 to that in 2000?
Ensure brevity in your answer.  1.03. What is the ratio of the Vaccinated children(%) of Low & middle income in 1998 to that in 2001?
Provide a succinct answer. 0.95. What is the ratio of the Vaccinated children(%) of Other small states in 1998 to that in 2001?
Offer a very short reply. 0.97. What is the ratio of the Vaccinated children(%) of Peru in 1998 to that in 2001?
Provide a short and direct response. 1.03. What is the ratio of the Vaccinated children(%) of Tanzania in 1998 to that in 2001?
Provide a short and direct response. 1.01. What is the ratio of the Vaccinated children(%) of Low & middle income in 1998 to that in 2002?
Give a very brief answer. 0.92. What is the ratio of the Vaccinated children(%) in Other small states in 1998 to that in 2002?
Give a very brief answer. 0.95. What is the ratio of the Vaccinated children(%) of Peru in 1998 to that in 2002?
Offer a terse response. 1.03. What is the ratio of the Vaccinated children(%) in Tanzania in 1998 to that in 2002?
Make the answer very short. 1.01. What is the ratio of the Vaccinated children(%) of Low & middle income in 1998 to that in 2003?
Give a very brief answer. 0.91. What is the ratio of the Vaccinated children(%) in Other small states in 1998 to that in 2003?
Your answer should be compact. 0.94. What is the ratio of the Vaccinated children(%) of Peru in 1998 to that in 2003?
Your answer should be compact. 1.02. What is the ratio of the Vaccinated children(%) of Tanzania in 1998 to that in 2003?
Give a very brief answer. 1.01. What is the ratio of the Vaccinated children(%) of Low & middle income in 1998 to that in 2004?
Provide a short and direct response. 0.9. What is the ratio of the Vaccinated children(%) of Other small states in 1998 to that in 2004?
Provide a succinct answer. 0.91. What is the ratio of the Vaccinated children(%) in Peru in 1998 to that in 2004?
Offer a very short reply. 0.98. What is the ratio of the Vaccinated children(%) of Tanzania in 1998 to that in 2004?
Offer a terse response. 1.01. What is the ratio of the Vaccinated children(%) of Low & middle income in 1998 to that in 2005?
Your answer should be very brief. 0.9. What is the ratio of the Vaccinated children(%) of Other small states in 1998 to that in 2005?
Your response must be concise. 0.93. What is the ratio of the Vaccinated children(%) of Peru in 1998 to that in 2005?
Provide a short and direct response. 0.98. What is the ratio of the Vaccinated children(%) in Low & middle income in 1999 to that in 2000?
Provide a succinct answer. 0.97. What is the ratio of the Vaccinated children(%) in Other small states in 1999 to that in 2000?
Your answer should be very brief. 1.02. What is the ratio of the Vaccinated children(%) of Tanzania in 1999 to that in 2000?
Give a very brief answer. 1.03. What is the ratio of the Vaccinated children(%) in Low & middle income in 1999 to that in 2001?
Offer a terse response. 0.97. What is the ratio of the Vaccinated children(%) in Other small states in 1999 to that in 2001?
Give a very brief answer. 0.97. What is the ratio of the Vaccinated children(%) of Peru in 1999 to that in 2001?
Keep it short and to the point. 1.05. What is the ratio of the Vaccinated children(%) in Tanzania in 1999 to that in 2001?
Offer a very short reply. 1.01. What is the ratio of the Vaccinated children(%) of Low & middle income in 1999 to that in 2002?
Provide a short and direct response. 0.94. What is the ratio of the Vaccinated children(%) of Other small states in 1999 to that in 2002?
Give a very brief answer. 0.95. What is the ratio of the Vaccinated children(%) in Peru in 1999 to that in 2002?
Make the answer very short. 1.05. What is the ratio of the Vaccinated children(%) of Tanzania in 1999 to that in 2002?
Give a very brief answer. 1.01. What is the ratio of the Vaccinated children(%) in Low & middle income in 1999 to that in 2003?
Your answer should be very brief. 0.93. What is the ratio of the Vaccinated children(%) of Other small states in 1999 to that in 2003?
Your answer should be compact. 0.94. What is the ratio of the Vaccinated children(%) of Peru in 1999 to that in 2003?
Ensure brevity in your answer.  1.03. What is the ratio of the Vaccinated children(%) in Tanzania in 1999 to that in 2003?
Your response must be concise. 1.01. What is the ratio of the Vaccinated children(%) of Low & middle income in 1999 to that in 2004?
Keep it short and to the point. 0.91. What is the ratio of the Vaccinated children(%) in Other small states in 1999 to that in 2004?
Your answer should be very brief. 0.91. What is the ratio of the Vaccinated children(%) of Peru in 1999 to that in 2004?
Keep it short and to the point. 1. What is the ratio of the Vaccinated children(%) of Tanzania in 1999 to that in 2004?
Provide a succinct answer. 1.01. What is the ratio of the Vaccinated children(%) of Low & middle income in 1999 to that in 2005?
Make the answer very short. 0.92. What is the ratio of the Vaccinated children(%) of Other small states in 1999 to that in 2005?
Your answer should be very brief. 0.93. What is the ratio of the Vaccinated children(%) in Tanzania in 1999 to that in 2005?
Provide a succinct answer. 1. What is the ratio of the Vaccinated children(%) in Low & middle income in 2000 to that in 2001?
Keep it short and to the point. 0.99. What is the ratio of the Vaccinated children(%) of Other small states in 2000 to that in 2001?
Offer a terse response. 0.96. What is the ratio of the Vaccinated children(%) in Peru in 2000 to that in 2001?
Your answer should be very brief. 1.06. What is the ratio of the Vaccinated children(%) in Tanzania in 2000 to that in 2001?
Provide a succinct answer. 0.99. What is the ratio of the Vaccinated children(%) in Low & middle income in 2000 to that in 2002?
Ensure brevity in your answer.  0.97. What is the ratio of the Vaccinated children(%) in Other small states in 2000 to that in 2002?
Keep it short and to the point. 0.93. What is the ratio of the Vaccinated children(%) of Peru in 2000 to that in 2002?
Offer a very short reply. 1.06. What is the ratio of the Vaccinated children(%) of Tanzania in 2000 to that in 2002?
Make the answer very short. 0.99. What is the ratio of the Vaccinated children(%) in Low & middle income in 2000 to that in 2003?
Keep it short and to the point. 0.96. What is the ratio of the Vaccinated children(%) of Other small states in 2000 to that in 2003?
Your response must be concise. 0.92. What is the ratio of the Vaccinated children(%) in Peru in 2000 to that in 2003?
Keep it short and to the point. 1.05. What is the ratio of the Vaccinated children(%) in Tanzania in 2000 to that in 2003?
Offer a terse response. 0.99. What is the ratio of the Vaccinated children(%) in Low & middle income in 2000 to that in 2004?
Keep it short and to the point. 0.94. What is the ratio of the Vaccinated children(%) in Other small states in 2000 to that in 2004?
Keep it short and to the point. 0.9. What is the ratio of the Vaccinated children(%) in Peru in 2000 to that in 2004?
Your answer should be compact. 1.02. What is the ratio of the Vaccinated children(%) in Tanzania in 2000 to that in 2004?
Provide a short and direct response. 0.99. What is the ratio of the Vaccinated children(%) of Low & middle income in 2000 to that in 2005?
Make the answer very short. 0.94. What is the ratio of the Vaccinated children(%) in Other small states in 2000 to that in 2005?
Provide a short and direct response. 0.91. What is the ratio of the Vaccinated children(%) in Peru in 2000 to that in 2005?
Provide a short and direct response. 1.02. What is the ratio of the Vaccinated children(%) of Tanzania in 2000 to that in 2005?
Give a very brief answer. 0.98. What is the ratio of the Vaccinated children(%) in Low & middle income in 2001 to that in 2002?
Give a very brief answer. 0.97. What is the ratio of the Vaccinated children(%) of Other small states in 2001 to that in 2002?
Provide a short and direct response. 0.97. What is the ratio of the Vaccinated children(%) of Peru in 2001 to that in 2002?
Your answer should be very brief. 1. What is the ratio of the Vaccinated children(%) in Low & middle income in 2001 to that in 2003?
Offer a very short reply. 0.96. What is the ratio of the Vaccinated children(%) in Other small states in 2001 to that in 2003?
Offer a terse response. 0.97. What is the ratio of the Vaccinated children(%) of Peru in 2001 to that in 2003?
Offer a terse response. 0.98. What is the ratio of the Vaccinated children(%) in Low & middle income in 2001 to that in 2004?
Offer a very short reply. 0.94. What is the ratio of the Vaccinated children(%) of Peru in 2001 to that in 2004?
Offer a very short reply. 0.95. What is the ratio of the Vaccinated children(%) in Low & middle income in 2001 to that in 2005?
Your answer should be very brief. 0.95. What is the ratio of the Vaccinated children(%) in Other small states in 2001 to that in 2005?
Your answer should be compact. 0.95. What is the ratio of the Vaccinated children(%) in Peru in 2001 to that in 2005?
Give a very brief answer. 0.95. What is the ratio of the Vaccinated children(%) in Peru in 2002 to that in 2003?
Provide a short and direct response. 0.98. What is the ratio of the Vaccinated children(%) of Tanzania in 2002 to that in 2003?
Give a very brief answer. 1. What is the ratio of the Vaccinated children(%) of Low & middle income in 2002 to that in 2004?
Offer a very short reply. 0.97. What is the ratio of the Vaccinated children(%) of Other small states in 2002 to that in 2004?
Your response must be concise. 0.96. What is the ratio of the Vaccinated children(%) of Peru in 2002 to that in 2004?
Provide a succinct answer. 0.95. What is the ratio of the Vaccinated children(%) in Tanzania in 2002 to that in 2004?
Make the answer very short. 1. What is the ratio of the Vaccinated children(%) in Low & middle income in 2002 to that in 2005?
Give a very brief answer. 0.97. What is the ratio of the Vaccinated children(%) in Other small states in 2002 to that in 2005?
Keep it short and to the point. 0.98. What is the ratio of the Vaccinated children(%) of Peru in 2002 to that in 2005?
Offer a very short reply. 0.95. What is the ratio of the Vaccinated children(%) in Low & middle income in 2003 to that in 2004?
Offer a terse response. 0.98. What is the ratio of the Vaccinated children(%) of Other small states in 2003 to that in 2004?
Make the answer very short. 0.97. What is the ratio of the Vaccinated children(%) of Peru in 2003 to that in 2004?
Provide a succinct answer. 0.97. What is the ratio of the Vaccinated children(%) of Tanzania in 2003 to that in 2004?
Keep it short and to the point. 1. What is the ratio of the Vaccinated children(%) in Low & middle income in 2003 to that in 2005?
Offer a terse response. 0.98. What is the ratio of the Vaccinated children(%) in Other small states in 2003 to that in 2005?
Make the answer very short. 0.98. What is the ratio of the Vaccinated children(%) of Peru in 2003 to that in 2005?
Provide a succinct answer. 0.97. What is the ratio of the Vaccinated children(%) of Tanzania in 2004 to that in 2005?
Make the answer very short. 0.99. What is the difference between the highest and the second highest Vaccinated children(%) of Low & middle income?
Your response must be concise. 0.2. What is the difference between the highest and the second highest Vaccinated children(%) of Other small states?
Your response must be concise. 1.06. What is the difference between the highest and the second highest Vaccinated children(%) in Peru?
Offer a terse response. 1. What is the difference between the highest and the lowest Vaccinated children(%) of Low & middle income?
Ensure brevity in your answer.  8.17. What is the difference between the highest and the lowest Vaccinated children(%) of Other small states?
Make the answer very short. 7.9. 